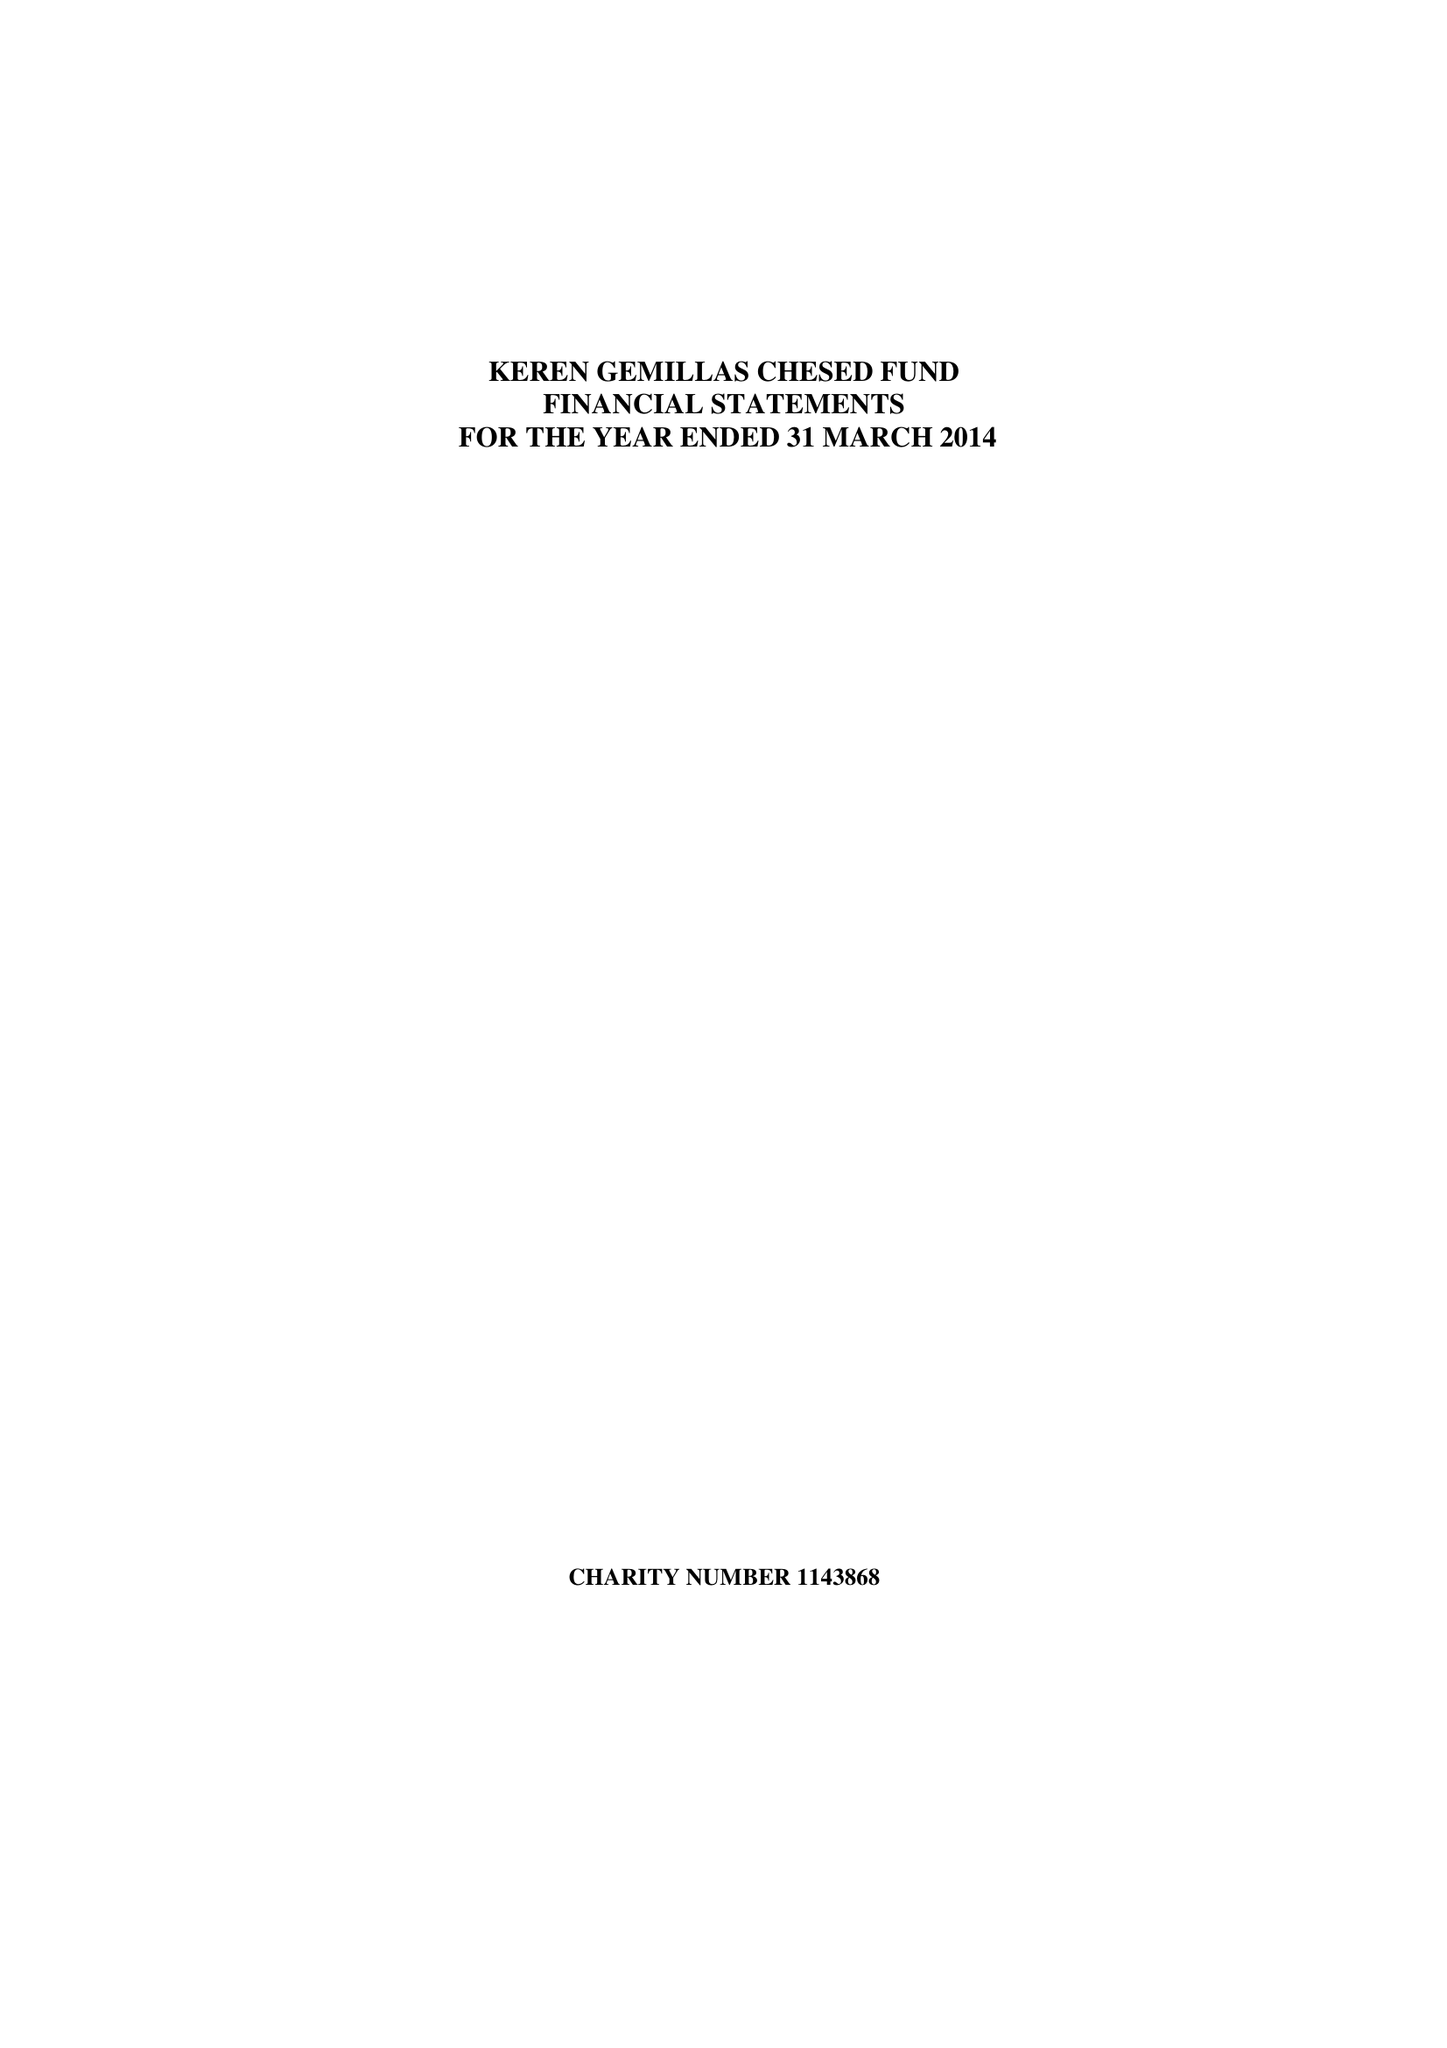What is the value for the address__post_town?
Answer the question using a single word or phrase. None 